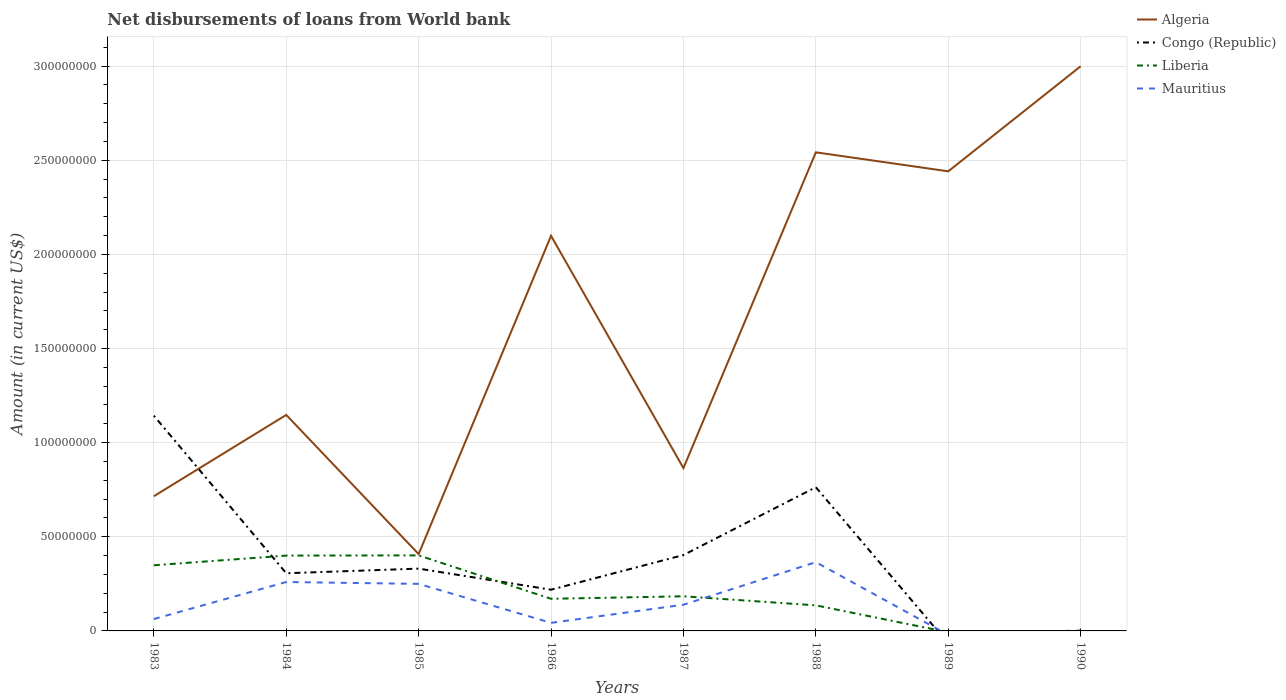Does the line corresponding to Liberia intersect with the line corresponding to Algeria?
Your response must be concise. No. What is the total amount of loan disbursed from World Bank in Liberia in the graph?
Your answer should be compact. -5.24e+06. What is the difference between the highest and the second highest amount of loan disbursed from World Bank in Algeria?
Provide a succinct answer. 2.59e+08. What is the difference between the highest and the lowest amount of loan disbursed from World Bank in Congo (Republic)?
Your answer should be compact. 3. Is the amount of loan disbursed from World Bank in Liberia strictly greater than the amount of loan disbursed from World Bank in Algeria over the years?
Ensure brevity in your answer.  Yes. How many lines are there?
Provide a succinct answer. 4. What is the difference between two consecutive major ticks on the Y-axis?
Your answer should be very brief. 5.00e+07. Are the values on the major ticks of Y-axis written in scientific E-notation?
Give a very brief answer. No. Does the graph contain any zero values?
Ensure brevity in your answer.  Yes. Where does the legend appear in the graph?
Your answer should be very brief. Top right. How many legend labels are there?
Offer a terse response. 4. How are the legend labels stacked?
Ensure brevity in your answer.  Vertical. What is the title of the graph?
Provide a succinct answer. Net disbursements of loans from World bank. What is the Amount (in current US$) of Algeria in 1983?
Make the answer very short. 7.15e+07. What is the Amount (in current US$) of Congo (Republic) in 1983?
Give a very brief answer. 1.14e+08. What is the Amount (in current US$) of Liberia in 1983?
Provide a succinct answer. 3.49e+07. What is the Amount (in current US$) in Mauritius in 1983?
Make the answer very short. 6.31e+06. What is the Amount (in current US$) in Algeria in 1984?
Ensure brevity in your answer.  1.15e+08. What is the Amount (in current US$) of Congo (Republic) in 1984?
Make the answer very short. 3.06e+07. What is the Amount (in current US$) of Liberia in 1984?
Give a very brief answer. 4.00e+07. What is the Amount (in current US$) of Mauritius in 1984?
Make the answer very short. 2.60e+07. What is the Amount (in current US$) of Algeria in 1985?
Make the answer very short. 4.08e+07. What is the Amount (in current US$) of Congo (Republic) in 1985?
Your answer should be very brief. 3.31e+07. What is the Amount (in current US$) of Liberia in 1985?
Make the answer very short. 4.01e+07. What is the Amount (in current US$) in Mauritius in 1985?
Offer a terse response. 2.50e+07. What is the Amount (in current US$) in Algeria in 1986?
Make the answer very short. 2.10e+08. What is the Amount (in current US$) in Congo (Republic) in 1986?
Give a very brief answer. 2.19e+07. What is the Amount (in current US$) of Liberia in 1986?
Provide a short and direct response. 1.71e+07. What is the Amount (in current US$) of Mauritius in 1986?
Keep it short and to the point. 4.29e+06. What is the Amount (in current US$) in Algeria in 1987?
Offer a very short reply. 8.65e+07. What is the Amount (in current US$) of Congo (Republic) in 1987?
Your answer should be very brief. 4.03e+07. What is the Amount (in current US$) of Liberia in 1987?
Make the answer very short. 1.84e+07. What is the Amount (in current US$) in Mauritius in 1987?
Make the answer very short. 1.39e+07. What is the Amount (in current US$) of Algeria in 1988?
Your response must be concise. 2.54e+08. What is the Amount (in current US$) of Congo (Republic) in 1988?
Provide a short and direct response. 7.63e+07. What is the Amount (in current US$) of Liberia in 1988?
Provide a short and direct response. 1.36e+07. What is the Amount (in current US$) in Mauritius in 1988?
Your answer should be compact. 3.65e+07. What is the Amount (in current US$) of Algeria in 1989?
Provide a short and direct response. 2.44e+08. What is the Amount (in current US$) in Mauritius in 1989?
Your response must be concise. 0. What is the Amount (in current US$) in Algeria in 1990?
Your answer should be very brief. 3.00e+08. What is the Amount (in current US$) in Congo (Republic) in 1990?
Offer a terse response. 0. What is the Amount (in current US$) of Liberia in 1990?
Your answer should be compact. 0. What is the Amount (in current US$) of Mauritius in 1990?
Provide a succinct answer. 2.60e+05. Across all years, what is the maximum Amount (in current US$) in Algeria?
Give a very brief answer. 3.00e+08. Across all years, what is the maximum Amount (in current US$) of Congo (Republic)?
Make the answer very short. 1.14e+08. Across all years, what is the maximum Amount (in current US$) in Liberia?
Your answer should be very brief. 4.01e+07. Across all years, what is the maximum Amount (in current US$) in Mauritius?
Offer a terse response. 3.65e+07. Across all years, what is the minimum Amount (in current US$) in Algeria?
Your answer should be very brief. 4.08e+07. Across all years, what is the minimum Amount (in current US$) in Liberia?
Offer a very short reply. 0. What is the total Amount (in current US$) of Algeria in the graph?
Your answer should be very brief. 1.32e+09. What is the total Amount (in current US$) in Congo (Republic) in the graph?
Your answer should be very brief. 3.17e+08. What is the total Amount (in current US$) in Liberia in the graph?
Offer a very short reply. 1.64e+08. What is the total Amount (in current US$) in Mauritius in the graph?
Your response must be concise. 1.12e+08. What is the difference between the Amount (in current US$) in Algeria in 1983 and that in 1984?
Your answer should be very brief. -4.32e+07. What is the difference between the Amount (in current US$) of Congo (Republic) in 1983 and that in 1984?
Keep it short and to the point. 8.37e+07. What is the difference between the Amount (in current US$) of Liberia in 1983 and that in 1984?
Provide a short and direct response. -5.13e+06. What is the difference between the Amount (in current US$) of Mauritius in 1983 and that in 1984?
Your answer should be very brief. -1.97e+07. What is the difference between the Amount (in current US$) in Algeria in 1983 and that in 1985?
Make the answer very short. 3.07e+07. What is the difference between the Amount (in current US$) in Congo (Republic) in 1983 and that in 1985?
Ensure brevity in your answer.  8.12e+07. What is the difference between the Amount (in current US$) of Liberia in 1983 and that in 1985?
Keep it short and to the point. -5.24e+06. What is the difference between the Amount (in current US$) in Mauritius in 1983 and that in 1985?
Your response must be concise. -1.87e+07. What is the difference between the Amount (in current US$) in Algeria in 1983 and that in 1986?
Your response must be concise. -1.38e+08. What is the difference between the Amount (in current US$) of Congo (Republic) in 1983 and that in 1986?
Offer a very short reply. 9.24e+07. What is the difference between the Amount (in current US$) of Liberia in 1983 and that in 1986?
Your response must be concise. 1.78e+07. What is the difference between the Amount (in current US$) of Mauritius in 1983 and that in 1986?
Ensure brevity in your answer.  2.02e+06. What is the difference between the Amount (in current US$) in Algeria in 1983 and that in 1987?
Give a very brief answer. -1.49e+07. What is the difference between the Amount (in current US$) in Congo (Republic) in 1983 and that in 1987?
Your response must be concise. 7.40e+07. What is the difference between the Amount (in current US$) of Liberia in 1983 and that in 1987?
Give a very brief answer. 1.65e+07. What is the difference between the Amount (in current US$) of Mauritius in 1983 and that in 1987?
Your response must be concise. -7.61e+06. What is the difference between the Amount (in current US$) of Algeria in 1983 and that in 1988?
Offer a terse response. -1.83e+08. What is the difference between the Amount (in current US$) of Congo (Republic) in 1983 and that in 1988?
Offer a very short reply. 3.80e+07. What is the difference between the Amount (in current US$) in Liberia in 1983 and that in 1988?
Offer a terse response. 2.13e+07. What is the difference between the Amount (in current US$) in Mauritius in 1983 and that in 1988?
Provide a short and direct response. -3.02e+07. What is the difference between the Amount (in current US$) in Algeria in 1983 and that in 1989?
Give a very brief answer. -1.73e+08. What is the difference between the Amount (in current US$) in Algeria in 1983 and that in 1990?
Offer a terse response. -2.28e+08. What is the difference between the Amount (in current US$) of Mauritius in 1983 and that in 1990?
Make the answer very short. 6.05e+06. What is the difference between the Amount (in current US$) of Algeria in 1984 and that in 1985?
Offer a terse response. 7.39e+07. What is the difference between the Amount (in current US$) in Congo (Republic) in 1984 and that in 1985?
Make the answer very short. -2.46e+06. What is the difference between the Amount (in current US$) of Liberia in 1984 and that in 1985?
Offer a terse response. -1.11e+05. What is the difference between the Amount (in current US$) in Mauritius in 1984 and that in 1985?
Your response must be concise. 9.86e+05. What is the difference between the Amount (in current US$) of Algeria in 1984 and that in 1986?
Offer a very short reply. -9.51e+07. What is the difference between the Amount (in current US$) in Congo (Republic) in 1984 and that in 1986?
Offer a very short reply. 8.74e+06. What is the difference between the Amount (in current US$) in Liberia in 1984 and that in 1986?
Offer a very short reply. 2.29e+07. What is the difference between the Amount (in current US$) of Mauritius in 1984 and that in 1986?
Provide a short and direct response. 2.17e+07. What is the difference between the Amount (in current US$) of Algeria in 1984 and that in 1987?
Your answer should be compact. 2.82e+07. What is the difference between the Amount (in current US$) in Congo (Republic) in 1984 and that in 1987?
Your answer should be compact. -9.67e+06. What is the difference between the Amount (in current US$) of Liberia in 1984 and that in 1987?
Offer a terse response. 2.16e+07. What is the difference between the Amount (in current US$) of Mauritius in 1984 and that in 1987?
Keep it short and to the point. 1.21e+07. What is the difference between the Amount (in current US$) of Algeria in 1984 and that in 1988?
Your response must be concise. -1.39e+08. What is the difference between the Amount (in current US$) in Congo (Republic) in 1984 and that in 1988?
Offer a terse response. -4.57e+07. What is the difference between the Amount (in current US$) of Liberia in 1984 and that in 1988?
Ensure brevity in your answer.  2.64e+07. What is the difference between the Amount (in current US$) in Mauritius in 1984 and that in 1988?
Provide a succinct answer. -1.05e+07. What is the difference between the Amount (in current US$) in Algeria in 1984 and that in 1989?
Your response must be concise. -1.29e+08. What is the difference between the Amount (in current US$) of Algeria in 1984 and that in 1990?
Your answer should be very brief. -1.85e+08. What is the difference between the Amount (in current US$) of Mauritius in 1984 and that in 1990?
Make the answer very short. 2.57e+07. What is the difference between the Amount (in current US$) of Algeria in 1985 and that in 1986?
Offer a very short reply. -1.69e+08. What is the difference between the Amount (in current US$) in Congo (Republic) in 1985 and that in 1986?
Your answer should be very brief. 1.12e+07. What is the difference between the Amount (in current US$) in Liberia in 1985 and that in 1986?
Offer a very short reply. 2.31e+07. What is the difference between the Amount (in current US$) in Mauritius in 1985 and that in 1986?
Your answer should be very brief. 2.07e+07. What is the difference between the Amount (in current US$) in Algeria in 1985 and that in 1987?
Keep it short and to the point. -4.57e+07. What is the difference between the Amount (in current US$) in Congo (Republic) in 1985 and that in 1987?
Provide a short and direct response. -7.21e+06. What is the difference between the Amount (in current US$) in Liberia in 1985 and that in 1987?
Provide a short and direct response. 2.17e+07. What is the difference between the Amount (in current US$) in Mauritius in 1985 and that in 1987?
Offer a very short reply. 1.11e+07. What is the difference between the Amount (in current US$) of Algeria in 1985 and that in 1988?
Ensure brevity in your answer.  -2.13e+08. What is the difference between the Amount (in current US$) in Congo (Republic) in 1985 and that in 1988?
Provide a succinct answer. -4.32e+07. What is the difference between the Amount (in current US$) in Liberia in 1985 and that in 1988?
Provide a short and direct response. 2.65e+07. What is the difference between the Amount (in current US$) in Mauritius in 1985 and that in 1988?
Offer a terse response. -1.15e+07. What is the difference between the Amount (in current US$) of Algeria in 1985 and that in 1989?
Offer a terse response. -2.03e+08. What is the difference between the Amount (in current US$) of Algeria in 1985 and that in 1990?
Your response must be concise. -2.59e+08. What is the difference between the Amount (in current US$) of Mauritius in 1985 and that in 1990?
Give a very brief answer. 2.47e+07. What is the difference between the Amount (in current US$) in Algeria in 1986 and that in 1987?
Make the answer very short. 1.23e+08. What is the difference between the Amount (in current US$) of Congo (Republic) in 1986 and that in 1987?
Your answer should be compact. -1.84e+07. What is the difference between the Amount (in current US$) in Liberia in 1986 and that in 1987?
Offer a terse response. -1.33e+06. What is the difference between the Amount (in current US$) of Mauritius in 1986 and that in 1987?
Ensure brevity in your answer.  -9.62e+06. What is the difference between the Amount (in current US$) of Algeria in 1986 and that in 1988?
Offer a terse response. -4.43e+07. What is the difference between the Amount (in current US$) of Congo (Republic) in 1986 and that in 1988?
Your response must be concise. -5.44e+07. What is the difference between the Amount (in current US$) of Liberia in 1986 and that in 1988?
Your response must be concise. 3.48e+06. What is the difference between the Amount (in current US$) in Mauritius in 1986 and that in 1988?
Your response must be concise. -3.22e+07. What is the difference between the Amount (in current US$) in Algeria in 1986 and that in 1989?
Provide a short and direct response. -3.42e+07. What is the difference between the Amount (in current US$) of Algeria in 1986 and that in 1990?
Your response must be concise. -9.00e+07. What is the difference between the Amount (in current US$) of Mauritius in 1986 and that in 1990?
Offer a terse response. 4.03e+06. What is the difference between the Amount (in current US$) of Algeria in 1987 and that in 1988?
Your answer should be compact. -1.68e+08. What is the difference between the Amount (in current US$) of Congo (Republic) in 1987 and that in 1988?
Keep it short and to the point. -3.60e+07. What is the difference between the Amount (in current US$) of Liberia in 1987 and that in 1988?
Offer a very short reply. 4.81e+06. What is the difference between the Amount (in current US$) of Mauritius in 1987 and that in 1988?
Keep it short and to the point. -2.26e+07. What is the difference between the Amount (in current US$) of Algeria in 1987 and that in 1989?
Your response must be concise. -1.58e+08. What is the difference between the Amount (in current US$) of Algeria in 1987 and that in 1990?
Your response must be concise. -2.13e+08. What is the difference between the Amount (in current US$) of Mauritius in 1987 and that in 1990?
Offer a very short reply. 1.37e+07. What is the difference between the Amount (in current US$) in Algeria in 1988 and that in 1989?
Your answer should be very brief. 1.01e+07. What is the difference between the Amount (in current US$) in Algeria in 1988 and that in 1990?
Keep it short and to the point. -4.57e+07. What is the difference between the Amount (in current US$) in Mauritius in 1988 and that in 1990?
Make the answer very short. 3.63e+07. What is the difference between the Amount (in current US$) of Algeria in 1989 and that in 1990?
Offer a terse response. -5.58e+07. What is the difference between the Amount (in current US$) of Algeria in 1983 and the Amount (in current US$) of Congo (Republic) in 1984?
Offer a very short reply. 4.09e+07. What is the difference between the Amount (in current US$) in Algeria in 1983 and the Amount (in current US$) in Liberia in 1984?
Provide a succinct answer. 3.15e+07. What is the difference between the Amount (in current US$) in Algeria in 1983 and the Amount (in current US$) in Mauritius in 1984?
Your response must be concise. 4.56e+07. What is the difference between the Amount (in current US$) in Congo (Republic) in 1983 and the Amount (in current US$) in Liberia in 1984?
Your answer should be very brief. 7.43e+07. What is the difference between the Amount (in current US$) in Congo (Republic) in 1983 and the Amount (in current US$) in Mauritius in 1984?
Ensure brevity in your answer.  8.84e+07. What is the difference between the Amount (in current US$) of Liberia in 1983 and the Amount (in current US$) of Mauritius in 1984?
Give a very brief answer. 8.90e+06. What is the difference between the Amount (in current US$) in Algeria in 1983 and the Amount (in current US$) in Congo (Republic) in 1985?
Offer a very short reply. 3.85e+07. What is the difference between the Amount (in current US$) of Algeria in 1983 and the Amount (in current US$) of Liberia in 1985?
Provide a succinct answer. 3.14e+07. What is the difference between the Amount (in current US$) in Algeria in 1983 and the Amount (in current US$) in Mauritius in 1985?
Make the answer very short. 4.66e+07. What is the difference between the Amount (in current US$) in Congo (Republic) in 1983 and the Amount (in current US$) in Liberia in 1985?
Provide a succinct answer. 7.42e+07. What is the difference between the Amount (in current US$) of Congo (Republic) in 1983 and the Amount (in current US$) of Mauritius in 1985?
Offer a very short reply. 8.93e+07. What is the difference between the Amount (in current US$) of Liberia in 1983 and the Amount (in current US$) of Mauritius in 1985?
Give a very brief answer. 9.88e+06. What is the difference between the Amount (in current US$) of Algeria in 1983 and the Amount (in current US$) of Congo (Republic) in 1986?
Offer a terse response. 4.97e+07. What is the difference between the Amount (in current US$) in Algeria in 1983 and the Amount (in current US$) in Liberia in 1986?
Your answer should be very brief. 5.45e+07. What is the difference between the Amount (in current US$) in Algeria in 1983 and the Amount (in current US$) in Mauritius in 1986?
Make the answer very short. 6.73e+07. What is the difference between the Amount (in current US$) in Congo (Republic) in 1983 and the Amount (in current US$) in Liberia in 1986?
Your answer should be very brief. 9.73e+07. What is the difference between the Amount (in current US$) of Congo (Republic) in 1983 and the Amount (in current US$) of Mauritius in 1986?
Your response must be concise. 1.10e+08. What is the difference between the Amount (in current US$) of Liberia in 1983 and the Amount (in current US$) of Mauritius in 1986?
Ensure brevity in your answer.  3.06e+07. What is the difference between the Amount (in current US$) in Algeria in 1983 and the Amount (in current US$) in Congo (Republic) in 1987?
Ensure brevity in your answer.  3.12e+07. What is the difference between the Amount (in current US$) of Algeria in 1983 and the Amount (in current US$) of Liberia in 1987?
Your response must be concise. 5.31e+07. What is the difference between the Amount (in current US$) in Algeria in 1983 and the Amount (in current US$) in Mauritius in 1987?
Provide a succinct answer. 5.76e+07. What is the difference between the Amount (in current US$) of Congo (Republic) in 1983 and the Amount (in current US$) of Liberia in 1987?
Give a very brief answer. 9.59e+07. What is the difference between the Amount (in current US$) of Congo (Republic) in 1983 and the Amount (in current US$) of Mauritius in 1987?
Keep it short and to the point. 1.00e+08. What is the difference between the Amount (in current US$) of Liberia in 1983 and the Amount (in current US$) of Mauritius in 1987?
Provide a succinct answer. 2.10e+07. What is the difference between the Amount (in current US$) in Algeria in 1983 and the Amount (in current US$) in Congo (Republic) in 1988?
Provide a short and direct response. -4.77e+06. What is the difference between the Amount (in current US$) of Algeria in 1983 and the Amount (in current US$) of Liberia in 1988?
Your answer should be compact. 5.80e+07. What is the difference between the Amount (in current US$) in Algeria in 1983 and the Amount (in current US$) in Mauritius in 1988?
Ensure brevity in your answer.  3.50e+07. What is the difference between the Amount (in current US$) in Congo (Republic) in 1983 and the Amount (in current US$) in Liberia in 1988?
Make the answer very short. 1.01e+08. What is the difference between the Amount (in current US$) of Congo (Republic) in 1983 and the Amount (in current US$) of Mauritius in 1988?
Provide a succinct answer. 7.78e+07. What is the difference between the Amount (in current US$) of Liberia in 1983 and the Amount (in current US$) of Mauritius in 1988?
Keep it short and to the point. -1.65e+06. What is the difference between the Amount (in current US$) in Algeria in 1983 and the Amount (in current US$) in Mauritius in 1990?
Make the answer very short. 7.13e+07. What is the difference between the Amount (in current US$) of Congo (Republic) in 1983 and the Amount (in current US$) of Mauritius in 1990?
Your response must be concise. 1.14e+08. What is the difference between the Amount (in current US$) of Liberia in 1983 and the Amount (in current US$) of Mauritius in 1990?
Your answer should be compact. 3.46e+07. What is the difference between the Amount (in current US$) of Algeria in 1984 and the Amount (in current US$) of Congo (Republic) in 1985?
Give a very brief answer. 8.16e+07. What is the difference between the Amount (in current US$) in Algeria in 1984 and the Amount (in current US$) in Liberia in 1985?
Give a very brief answer. 7.46e+07. What is the difference between the Amount (in current US$) of Algeria in 1984 and the Amount (in current US$) of Mauritius in 1985?
Offer a very short reply. 8.97e+07. What is the difference between the Amount (in current US$) in Congo (Republic) in 1984 and the Amount (in current US$) in Liberia in 1985?
Keep it short and to the point. -9.49e+06. What is the difference between the Amount (in current US$) of Congo (Republic) in 1984 and the Amount (in current US$) of Mauritius in 1985?
Provide a short and direct response. 5.64e+06. What is the difference between the Amount (in current US$) in Liberia in 1984 and the Amount (in current US$) in Mauritius in 1985?
Make the answer very short. 1.50e+07. What is the difference between the Amount (in current US$) of Algeria in 1984 and the Amount (in current US$) of Congo (Republic) in 1986?
Give a very brief answer. 9.28e+07. What is the difference between the Amount (in current US$) of Algeria in 1984 and the Amount (in current US$) of Liberia in 1986?
Offer a very short reply. 9.77e+07. What is the difference between the Amount (in current US$) of Algeria in 1984 and the Amount (in current US$) of Mauritius in 1986?
Offer a terse response. 1.10e+08. What is the difference between the Amount (in current US$) in Congo (Republic) in 1984 and the Amount (in current US$) in Liberia in 1986?
Keep it short and to the point. 1.36e+07. What is the difference between the Amount (in current US$) of Congo (Republic) in 1984 and the Amount (in current US$) of Mauritius in 1986?
Ensure brevity in your answer.  2.63e+07. What is the difference between the Amount (in current US$) of Liberia in 1984 and the Amount (in current US$) of Mauritius in 1986?
Your answer should be very brief. 3.57e+07. What is the difference between the Amount (in current US$) of Algeria in 1984 and the Amount (in current US$) of Congo (Republic) in 1987?
Ensure brevity in your answer.  7.44e+07. What is the difference between the Amount (in current US$) of Algeria in 1984 and the Amount (in current US$) of Liberia in 1987?
Your response must be concise. 9.63e+07. What is the difference between the Amount (in current US$) of Algeria in 1984 and the Amount (in current US$) of Mauritius in 1987?
Provide a succinct answer. 1.01e+08. What is the difference between the Amount (in current US$) in Congo (Republic) in 1984 and the Amount (in current US$) in Liberia in 1987?
Provide a succinct answer. 1.22e+07. What is the difference between the Amount (in current US$) in Congo (Republic) in 1984 and the Amount (in current US$) in Mauritius in 1987?
Provide a short and direct response. 1.67e+07. What is the difference between the Amount (in current US$) of Liberia in 1984 and the Amount (in current US$) of Mauritius in 1987?
Your response must be concise. 2.61e+07. What is the difference between the Amount (in current US$) of Algeria in 1984 and the Amount (in current US$) of Congo (Republic) in 1988?
Your answer should be compact. 3.84e+07. What is the difference between the Amount (in current US$) of Algeria in 1984 and the Amount (in current US$) of Liberia in 1988?
Your answer should be very brief. 1.01e+08. What is the difference between the Amount (in current US$) of Algeria in 1984 and the Amount (in current US$) of Mauritius in 1988?
Keep it short and to the point. 7.82e+07. What is the difference between the Amount (in current US$) of Congo (Republic) in 1984 and the Amount (in current US$) of Liberia in 1988?
Offer a terse response. 1.70e+07. What is the difference between the Amount (in current US$) of Congo (Republic) in 1984 and the Amount (in current US$) of Mauritius in 1988?
Offer a terse response. -5.90e+06. What is the difference between the Amount (in current US$) in Liberia in 1984 and the Amount (in current US$) in Mauritius in 1988?
Provide a short and direct response. 3.48e+06. What is the difference between the Amount (in current US$) of Algeria in 1984 and the Amount (in current US$) of Mauritius in 1990?
Give a very brief answer. 1.14e+08. What is the difference between the Amount (in current US$) of Congo (Republic) in 1984 and the Amount (in current US$) of Mauritius in 1990?
Offer a very short reply. 3.04e+07. What is the difference between the Amount (in current US$) of Liberia in 1984 and the Amount (in current US$) of Mauritius in 1990?
Give a very brief answer. 3.97e+07. What is the difference between the Amount (in current US$) of Algeria in 1985 and the Amount (in current US$) of Congo (Republic) in 1986?
Your answer should be very brief. 1.89e+07. What is the difference between the Amount (in current US$) in Algeria in 1985 and the Amount (in current US$) in Liberia in 1986?
Your answer should be compact. 2.37e+07. What is the difference between the Amount (in current US$) in Algeria in 1985 and the Amount (in current US$) in Mauritius in 1986?
Offer a terse response. 3.65e+07. What is the difference between the Amount (in current US$) of Congo (Republic) in 1985 and the Amount (in current US$) of Liberia in 1986?
Provide a succinct answer. 1.60e+07. What is the difference between the Amount (in current US$) of Congo (Republic) in 1985 and the Amount (in current US$) of Mauritius in 1986?
Ensure brevity in your answer.  2.88e+07. What is the difference between the Amount (in current US$) of Liberia in 1985 and the Amount (in current US$) of Mauritius in 1986?
Ensure brevity in your answer.  3.58e+07. What is the difference between the Amount (in current US$) of Algeria in 1985 and the Amount (in current US$) of Congo (Republic) in 1987?
Provide a succinct answer. 5.12e+05. What is the difference between the Amount (in current US$) in Algeria in 1985 and the Amount (in current US$) in Liberia in 1987?
Give a very brief answer. 2.24e+07. What is the difference between the Amount (in current US$) of Algeria in 1985 and the Amount (in current US$) of Mauritius in 1987?
Your response must be concise. 2.69e+07. What is the difference between the Amount (in current US$) of Congo (Republic) in 1985 and the Amount (in current US$) of Liberia in 1987?
Offer a very short reply. 1.47e+07. What is the difference between the Amount (in current US$) in Congo (Republic) in 1985 and the Amount (in current US$) in Mauritius in 1987?
Keep it short and to the point. 1.92e+07. What is the difference between the Amount (in current US$) of Liberia in 1985 and the Amount (in current US$) of Mauritius in 1987?
Keep it short and to the point. 2.62e+07. What is the difference between the Amount (in current US$) in Algeria in 1985 and the Amount (in current US$) in Congo (Republic) in 1988?
Make the answer very short. -3.55e+07. What is the difference between the Amount (in current US$) in Algeria in 1985 and the Amount (in current US$) in Liberia in 1988?
Provide a short and direct response. 2.72e+07. What is the difference between the Amount (in current US$) in Algeria in 1985 and the Amount (in current US$) in Mauritius in 1988?
Your answer should be compact. 4.28e+06. What is the difference between the Amount (in current US$) in Congo (Republic) in 1985 and the Amount (in current US$) in Liberia in 1988?
Your response must be concise. 1.95e+07. What is the difference between the Amount (in current US$) in Congo (Republic) in 1985 and the Amount (in current US$) in Mauritius in 1988?
Offer a very short reply. -3.44e+06. What is the difference between the Amount (in current US$) in Liberia in 1985 and the Amount (in current US$) in Mauritius in 1988?
Your response must be concise. 3.59e+06. What is the difference between the Amount (in current US$) in Algeria in 1985 and the Amount (in current US$) in Mauritius in 1990?
Your answer should be very brief. 4.06e+07. What is the difference between the Amount (in current US$) of Congo (Republic) in 1985 and the Amount (in current US$) of Mauritius in 1990?
Give a very brief answer. 3.28e+07. What is the difference between the Amount (in current US$) in Liberia in 1985 and the Amount (in current US$) in Mauritius in 1990?
Make the answer very short. 3.99e+07. What is the difference between the Amount (in current US$) of Algeria in 1986 and the Amount (in current US$) of Congo (Republic) in 1987?
Offer a very short reply. 1.70e+08. What is the difference between the Amount (in current US$) of Algeria in 1986 and the Amount (in current US$) of Liberia in 1987?
Keep it short and to the point. 1.91e+08. What is the difference between the Amount (in current US$) in Algeria in 1986 and the Amount (in current US$) in Mauritius in 1987?
Provide a short and direct response. 1.96e+08. What is the difference between the Amount (in current US$) of Congo (Republic) in 1986 and the Amount (in current US$) of Liberia in 1987?
Your response must be concise. 3.50e+06. What is the difference between the Amount (in current US$) in Congo (Republic) in 1986 and the Amount (in current US$) in Mauritius in 1987?
Ensure brevity in your answer.  7.98e+06. What is the difference between the Amount (in current US$) of Liberia in 1986 and the Amount (in current US$) of Mauritius in 1987?
Offer a terse response. 3.15e+06. What is the difference between the Amount (in current US$) in Algeria in 1986 and the Amount (in current US$) in Congo (Republic) in 1988?
Offer a terse response. 1.34e+08. What is the difference between the Amount (in current US$) of Algeria in 1986 and the Amount (in current US$) of Liberia in 1988?
Your answer should be compact. 1.96e+08. What is the difference between the Amount (in current US$) in Algeria in 1986 and the Amount (in current US$) in Mauritius in 1988?
Your response must be concise. 1.73e+08. What is the difference between the Amount (in current US$) of Congo (Republic) in 1986 and the Amount (in current US$) of Liberia in 1988?
Make the answer very short. 8.31e+06. What is the difference between the Amount (in current US$) in Congo (Republic) in 1986 and the Amount (in current US$) in Mauritius in 1988?
Keep it short and to the point. -1.46e+07. What is the difference between the Amount (in current US$) in Liberia in 1986 and the Amount (in current US$) in Mauritius in 1988?
Provide a short and direct response. -1.95e+07. What is the difference between the Amount (in current US$) of Algeria in 1986 and the Amount (in current US$) of Mauritius in 1990?
Make the answer very short. 2.10e+08. What is the difference between the Amount (in current US$) of Congo (Republic) in 1986 and the Amount (in current US$) of Mauritius in 1990?
Your response must be concise. 2.16e+07. What is the difference between the Amount (in current US$) of Liberia in 1986 and the Amount (in current US$) of Mauritius in 1990?
Your response must be concise. 1.68e+07. What is the difference between the Amount (in current US$) of Algeria in 1987 and the Amount (in current US$) of Congo (Republic) in 1988?
Ensure brevity in your answer.  1.02e+07. What is the difference between the Amount (in current US$) of Algeria in 1987 and the Amount (in current US$) of Liberia in 1988?
Offer a very short reply. 7.29e+07. What is the difference between the Amount (in current US$) of Algeria in 1987 and the Amount (in current US$) of Mauritius in 1988?
Make the answer very short. 5.00e+07. What is the difference between the Amount (in current US$) of Congo (Republic) in 1987 and the Amount (in current US$) of Liberia in 1988?
Provide a short and direct response. 2.67e+07. What is the difference between the Amount (in current US$) of Congo (Republic) in 1987 and the Amount (in current US$) of Mauritius in 1988?
Make the answer very short. 3.77e+06. What is the difference between the Amount (in current US$) of Liberia in 1987 and the Amount (in current US$) of Mauritius in 1988?
Offer a very short reply. -1.81e+07. What is the difference between the Amount (in current US$) of Algeria in 1987 and the Amount (in current US$) of Mauritius in 1990?
Ensure brevity in your answer.  8.62e+07. What is the difference between the Amount (in current US$) of Congo (Republic) in 1987 and the Amount (in current US$) of Mauritius in 1990?
Provide a succinct answer. 4.00e+07. What is the difference between the Amount (in current US$) in Liberia in 1987 and the Amount (in current US$) in Mauritius in 1990?
Offer a very short reply. 1.81e+07. What is the difference between the Amount (in current US$) in Algeria in 1988 and the Amount (in current US$) in Mauritius in 1990?
Your response must be concise. 2.54e+08. What is the difference between the Amount (in current US$) of Congo (Republic) in 1988 and the Amount (in current US$) of Mauritius in 1990?
Your answer should be compact. 7.61e+07. What is the difference between the Amount (in current US$) in Liberia in 1988 and the Amount (in current US$) in Mauritius in 1990?
Make the answer very short. 1.33e+07. What is the difference between the Amount (in current US$) of Algeria in 1989 and the Amount (in current US$) of Mauritius in 1990?
Offer a very short reply. 2.44e+08. What is the average Amount (in current US$) in Algeria per year?
Your response must be concise. 1.65e+08. What is the average Amount (in current US$) in Congo (Republic) per year?
Ensure brevity in your answer.  3.96e+07. What is the average Amount (in current US$) of Liberia per year?
Give a very brief answer. 2.05e+07. What is the average Amount (in current US$) of Mauritius per year?
Keep it short and to the point. 1.40e+07. In the year 1983, what is the difference between the Amount (in current US$) in Algeria and Amount (in current US$) in Congo (Republic)?
Your answer should be very brief. -4.28e+07. In the year 1983, what is the difference between the Amount (in current US$) of Algeria and Amount (in current US$) of Liberia?
Keep it short and to the point. 3.67e+07. In the year 1983, what is the difference between the Amount (in current US$) of Algeria and Amount (in current US$) of Mauritius?
Provide a short and direct response. 6.52e+07. In the year 1983, what is the difference between the Amount (in current US$) in Congo (Republic) and Amount (in current US$) in Liberia?
Your answer should be very brief. 7.95e+07. In the year 1983, what is the difference between the Amount (in current US$) of Congo (Republic) and Amount (in current US$) of Mauritius?
Make the answer very short. 1.08e+08. In the year 1983, what is the difference between the Amount (in current US$) in Liberia and Amount (in current US$) in Mauritius?
Your answer should be compact. 2.86e+07. In the year 1984, what is the difference between the Amount (in current US$) in Algeria and Amount (in current US$) in Congo (Republic)?
Provide a short and direct response. 8.41e+07. In the year 1984, what is the difference between the Amount (in current US$) of Algeria and Amount (in current US$) of Liberia?
Keep it short and to the point. 7.47e+07. In the year 1984, what is the difference between the Amount (in current US$) of Algeria and Amount (in current US$) of Mauritius?
Provide a short and direct response. 8.88e+07. In the year 1984, what is the difference between the Amount (in current US$) in Congo (Republic) and Amount (in current US$) in Liberia?
Make the answer very short. -9.38e+06. In the year 1984, what is the difference between the Amount (in current US$) in Congo (Republic) and Amount (in current US$) in Mauritius?
Give a very brief answer. 4.65e+06. In the year 1984, what is the difference between the Amount (in current US$) of Liberia and Amount (in current US$) of Mauritius?
Your response must be concise. 1.40e+07. In the year 1985, what is the difference between the Amount (in current US$) of Algeria and Amount (in current US$) of Congo (Republic)?
Make the answer very short. 7.72e+06. In the year 1985, what is the difference between the Amount (in current US$) of Algeria and Amount (in current US$) of Liberia?
Offer a terse response. 6.94e+05. In the year 1985, what is the difference between the Amount (in current US$) in Algeria and Amount (in current US$) in Mauritius?
Offer a very short reply. 1.58e+07. In the year 1985, what is the difference between the Amount (in current US$) in Congo (Republic) and Amount (in current US$) in Liberia?
Provide a succinct answer. -7.03e+06. In the year 1985, what is the difference between the Amount (in current US$) of Congo (Republic) and Amount (in current US$) of Mauritius?
Offer a terse response. 8.10e+06. In the year 1985, what is the difference between the Amount (in current US$) in Liberia and Amount (in current US$) in Mauritius?
Keep it short and to the point. 1.51e+07. In the year 1986, what is the difference between the Amount (in current US$) in Algeria and Amount (in current US$) in Congo (Republic)?
Offer a very short reply. 1.88e+08. In the year 1986, what is the difference between the Amount (in current US$) of Algeria and Amount (in current US$) of Liberia?
Provide a short and direct response. 1.93e+08. In the year 1986, what is the difference between the Amount (in current US$) of Algeria and Amount (in current US$) of Mauritius?
Your answer should be compact. 2.06e+08. In the year 1986, what is the difference between the Amount (in current US$) of Congo (Republic) and Amount (in current US$) of Liberia?
Your response must be concise. 4.83e+06. In the year 1986, what is the difference between the Amount (in current US$) of Congo (Republic) and Amount (in current US$) of Mauritius?
Ensure brevity in your answer.  1.76e+07. In the year 1986, what is the difference between the Amount (in current US$) of Liberia and Amount (in current US$) of Mauritius?
Provide a short and direct response. 1.28e+07. In the year 1987, what is the difference between the Amount (in current US$) in Algeria and Amount (in current US$) in Congo (Republic)?
Offer a very short reply. 4.62e+07. In the year 1987, what is the difference between the Amount (in current US$) in Algeria and Amount (in current US$) in Liberia?
Ensure brevity in your answer.  6.81e+07. In the year 1987, what is the difference between the Amount (in current US$) of Algeria and Amount (in current US$) of Mauritius?
Your response must be concise. 7.26e+07. In the year 1987, what is the difference between the Amount (in current US$) in Congo (Republic) and Amount (in current US$) in Liberia?
Provide a short and direct response. 2.19e+07. In the year 1987, what is the difference between the Amount (in current US$) in Congo (Republic) and Amount (in current US$) in Mauritius?
Offer a very short reply. 2.64e+07. In the year 1987, what is the difference between the Amount (in current US$) in Liberia and Amount (in current US$) in Mauritius?
Offer a very short reply. 4.48e+06. In the year 1988, what is the difference between the Amount (in current US$) in Algeria and Amount (in current US$) in Congo (Republic)?
Make the answer very short. 1.78e+08. In the year 1988, what is the difference between the Amount (in current US$) in Algeria and Amount (in current US$) in Liberia?
Provide a short and direct response. 2.41e+08. In the year 1988, what is the difference between the Amount (in current US$) of Algeria and Amount (in current US$) of Mauritius?
Your answer should be compact. 2.18e+08. In the year 1988, what is the difference between the Amount (in current US$) in Congo (Republic) and Amount (in current US$) in Liberia?
Ensure brevity in your answer.  6.27e+07. In the year 1988, what is the difference between the Amount (in current US$) of Congo (Republic) and Amount (in current US$) of Mauritius?
Offer a very short reply. 3.98e+07. In the year 1988, what is the difference between the Amount (in current US$) in Liberia and Amount (in current US$) in Mauritius?
Provide a short and direct response. -2.29e+07. In the year 1990, what is the difference between the Amount (in current US$) in Algeria and Amount (in current US$) in Mauritius?
Keep it short and to the point. 3.00e+08. What is the ratio of the Amount (in current US$) in Algeria in 1983 to that in 1984?
Offer a very short reply. 0.62. What is the ratio of the Amount (in current US$) in Congo (Republic) in 1983 to that in 1984?
Give a very brief answer. 3.73. What is the ratio of the Amount (in current US$) in Liberia in 1983 to that in 1984?
Keep it short and to the point. 0.87. What is the ratio of the Amount (in current US$) in Mauritius in 1983 to that in 1984?
Provide a succinct answer. 0.24. What is the ratio of the Amount (in current US$) of Algeria in 1983 to that in 1985?
Ensure brevity in your answer.  1.75. What is the ratio of the Amount (in current US$) in Congo (Republic) in 1983 to that in 1985?
Provide a succinct answer. 3.46. What is the ratio of the Amount (in current US$) in Liberia in 1983 to that in 1985?
Offer a terse response. 0.87. What is the ratio of the Amount (in current US$) in Mauritius in 1983 to that in 1985?
Give a very brief answer. 0.25. What is the ratio of the Amount (in current US$) in Algeria in 1983 to that in 1986?
Ensure brevity in your answer.  0.34. What is the ratio of the Amount (in current US$) of Congo (Republic) in 1983 to that in 1986?
Give a very brief answer. 5.22. What is the ratio of the Amount (in current US$) of Liberia in 1983 to that in 1986?
Your answer should be very brief. 2.04. What is the ratio of the Amount (in current US$) of Mauritius in 1983 to that in 1986?
Offer a terse response. 1.47. What is the ratio of the Amount (in current US$) of Algeria in 1983 to that in 1987?
Keep it short and to the point. 0.83. What is the ratio of the Amount (in current US$) in Congo (Republic) in 1983 to that in 1987?
Your answer should be very brief. 2.84. What is the ratio of the Amount (in current US$) of Liberia in 1983 to that in 1987?
Offer a terse response. 1.9. What is the ratio of the Amount (in current US$) in Mauritius in 1983 to that in 1987?
Your response must be concise. 0.45. What is the ratio of the Amount (in current US$) of Algeria in 1983 to that in 1988?
Your answer should be compact. 0.28. What is the ratio of the Amount (in current US$) of Congo (Republic) in 1983 to that in 1988?
Ensure brevity in your answer.  1.5. What is the ratio of the Amount (in current US$) of Liberia in 1983 to that in 1988?
Make the answer very short. 2.57. What is the ratio of the Amount (in current US$) of Mauritius in 1983 to that in 1988?
Ensure brevity in your answer.  0.17. What is the ratio of the Amount (in current US$) of Algeria in 1983 to that in 1989?
Your response must be concise. 0.29. What is the ratio of the Amount (in current US$) in Algeria in 1983 to that in 1990?
Offer a very short reply. 0.24. What is the ratio of the Amount (in current US$) in Mauritius in 1983 to that in 1990?
Your answer should be compact. 24.25. What is the ratio of the Amount (in current US$) in Algeria in 1984 to that in 1985?
Keep it short and to the point. 2.81. What is the ratio of the Amount (in current US$) in Congo (Republic) in 1984 to that in 1985?
Offer a terse response. 0.93. What is the ratio of the Amount (in current US$) in Liberia in 1984 to that in 1985?
Provide a short and direct response. 1. What is the ratio of the Amount (in current US$) in Mauritius in 1984 to that in 1985?
Make the answer very short. 1.04. What is the ratio of the Amount (in current US$) of Algeria in 1984 to that in 1986?
Your answer should be compact. 0.55. What is the ratio of the Amount (in current US$) in Congo (Republic) in 1984 to that in 1986?
Keep it short and to the point. 1.4. What is the ratio of the Amount (in current US$) of Liberia in 1984 to that in 1986?
Your answer should be very brief. 2.34. What is the ratio of the Amount (in current US$) of Mauritius in 1984 to that in 1986?
Your response must be concise. 6.05. What is the ratio of the Amount (in current US$) of Algeria in 1984 to that in 1987?
Make the answer very short. 1.33. What is the ratio of the Amount (in current US$) of Congo (Republic) in 1984 to that in 1987?
Ensure brevity in your answer.  0.76. What is the ratio of the Amount (in current US$) of Liberia in 1984 to that in 1987?
Provide a succinct answer. 2.17. What is the ratio of the Amount (in current US$) in Mauritius in 1984 to that in 1987?
Offer a very short reply. 1.87. What is the ratio of the Amount (in current US$) in Algeria in 1984 to that in 1988?
Offer a very short reply. 0.45. What is the ratio of the Amount (in current US$) of Congo (Republic) in 1984 to that in 1988?
Provide a succinct answer. 0.4. What is the ratio of the Amount (in current US$) of Liberia in 1984 to that in 1988?
Your answer should be very brief. 2.95. What is the ratio of the Amount (in current US$) of Mauritius in 1984 to that in 1988?
Ensure brevity in your answer.  0.71. What is the ratio of the Amount (in current US$) of Algeria in 1984 to that in 1989?
Provide a succinct answer. 0.47. What is the ratio of the Amount (in current US$) of Algeria in 1984 to that in 1990?
Your answer should be compact. 0.38. What is the ratio of the Amount (in current US$) in Mauritius in 1984 to that in 1990?
Provide a short and direct response. 99.91. What is the ratio of the Amount (in current US$) in Algeria in 1985 to that in 1986?
Offer a terse response. 0.19. What is the ratio of the Amount (in current US$) in Congo (Republic) in 1985 to that in 1986?
Keep it short and to the point. 1.51. What is the ratio of the Amount (in current US$) of Liberia in 1985 to that in 1986?
Offer a very short reply. 2.35. What is the ratio of the Amount (in current US$) of Mauritius in 1985 to that in 1986?
Offer a very short reply. 5.83. What is the ratio of the Amount (in current US$) of Algeria in 1985 to that in 1987?
Offer a terse response. 0.47. What is the ratio of the Amount (in current US$) of Congo (Republic) in 1985 to that in 1987?
Keep it short and to the point. 0.82. What is the ratio of the Amount (in current US$) in Liberia in 1985 to that in 1987?
Ensure brevity in your answer.  2.18. What is the ratio of the Amount (in current US$) of Mauritius in 1985 to that in 1987?
Provide a succinct answer. 1.8. What is the ratio of the Amount (in current US$) in Algeria in 1985 to that in 1988?
Ensure brevity in your answer.  0.16. What is the ratio of the Amount (in current US$) in Congo (Republic) in 1985 to that in 1988?
Keep it short and to the point. 0.43. What is the ratio of the Amount (in current US$) in Liberia in 1985 to that in 1988?
Offer a terse response. 2.95. What is the ratio of the Amount (in current US$) in Mauritius in 1985 to that in 1988?
Offer a terse response. 0.68. What is the ratio of the Amount (in current US$) in Algeria in 1985 to that in 1989?
Offer a very short reply. 0.17. What is the ratio of the Amount (in current US$) in Algeria in 1985 to that in 1990?
Make the answer very short. 0.14. What is the ratio of the Amount (in current US$) in Mauritius in 1985 to that in 1990?
Offer a terse response. 96.12. What is the ratio of the Amount (in current US$) in Algeria in 1986 to that in 1987?
Give a very brief answer. 2.43. What is the ratio of the Amount (in current US$) of Congo (Republic) in 1986 to that in 1987?
Make the answer very short. 0.54. What is the ratio of the Amount (in current US$) in Liberia in 1986 to that in 1987?
Your answer should be very brief. 0.93. What is the ratio of the Amount (in current US$) of Mauritius in 1986 to that in 1987?
Your response must be concise. 0.31. What is the ratio of the Amount (in current US$) in Algeria in 1986 to that in 1988?
Keep it short and to the point. 0.83. What is the ratio of the Amount (in current US$) in Congo (Republic) in 1986 to that in 1988?
Provide a succinct answer. 0.29. What is the ratio of the Amount (in current US$) in Liberia in 1986 to that in 1988?
Provide a short and direct response. 1.26. What is the ratio of the Amount (in current US$) in Mauritius in 1986 to that in 1988?
Give a very brief answer. 0.12. What is the ratio of the Amount (in current US$) in Algeria in 1986 to that in 1989?
Ensure brevity in your answer.  0.86. What is the ratio of the Amount (in current US$) of Algeria in 1986 to that in 1990?
Your answer should be compact. 0.7. What is the ratio of the Amount (in current US$) of Mauritius in 1986 to that in 1990?
Your answer should be very brief. 16.5. What is the ratio of the Amount (in current US$) of Algeria in 1987 to that in 1988?
Make the answer very short. 0.34. What is the ratio of the Amount (in current US$) in Congo (Republic) in 1987 to that in 1988?
Offer a terse response. 0.53. What is the ratio of the Amount (in current US$) of Liberia in 1987 to that in 1988?
Keep it short and to the point. 1.35. What is the ratio of the Amount (in current US$) in Mauritius in 1987 to that in 1988?
Provide a succinct answer. 0.38. What is the ratio of the Amount (in current US$) of Algeria in 1987 to that in 1989?
Ensure brevity in your answer.  0.35. What is the ratio of the Amount (in current US$) of Algeria in 1987 to that in 1990?
Make the answer very short. 0.29. What is the ratio of the Amount (in current US$) in Mauritius in 1987 to that in 1990?
Give a very brief answer. 53.51. What is the ratio of the Amount (in current US$) in Algeria in 1988 to that in 1989?
Give a very brief answer. 1.04. What is the ratio of the Amount (in current US$) of Algeria in 1988 to that in 1990?
Make the answer very short. 0.85. What is the ratio of the Amount (in current US$) of Mauritius in 1988 to that in 1990?
Make the answer very short. 140.48. What is the ratio of the Amount (in current US$) of Algeria in 1989 to that in 1990?
Ensure brevity in your answer.  0.81. What is the difference between the highest and the second highest Amount (in current US$) in Algeria?
Provide a succinct answer. 4.57e+07. What is the difference between the highest and the second highest Amount (in current US$) in Congo (Republic)?
Keep it short and to the point. 3.80e+07. What is the difference between the highest and the second highest Amount (in current US$) of Liberia?
Give a very brief answer. 1.11e+05. What is the difference between the highest and the second highest Amount (in current US$) in Mauritius?
Your response must be concise. 1.05e+07. What is the difference between the highest and the lowest Amount (in current US$) in Algeria?
Your response must be concise. 2.59e+08. What is the difference between the highest and the lowest Amount (in current US$) of Congo (Republic)?
Provide a succinct answer. 1.14e+08. What is the difference between the highest and the lowest Amount (in current US$) in Liberia?
Ensure brevity in your answer.  4.01e+07. What is the difference between the highest and the lowest Amount (in current US$) of Mauritius?
Provide a short and direct response. 3.65e+07. 